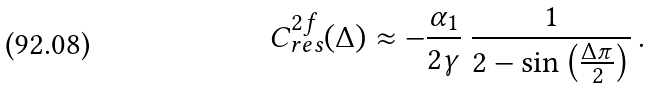Convert formula to latex. <formula><loc_0><loc_0><loc_500><loc_500>C _ { r e s } ^ { 2 f } ( \Delta ) \approx - \frac { \alpha _ { 1 } } { 2 \gamma } \ \frac { 1 } { 2 - \sin \left ( \frac { \Delta \pi } { 2 } \right ) } \, .</formula> 